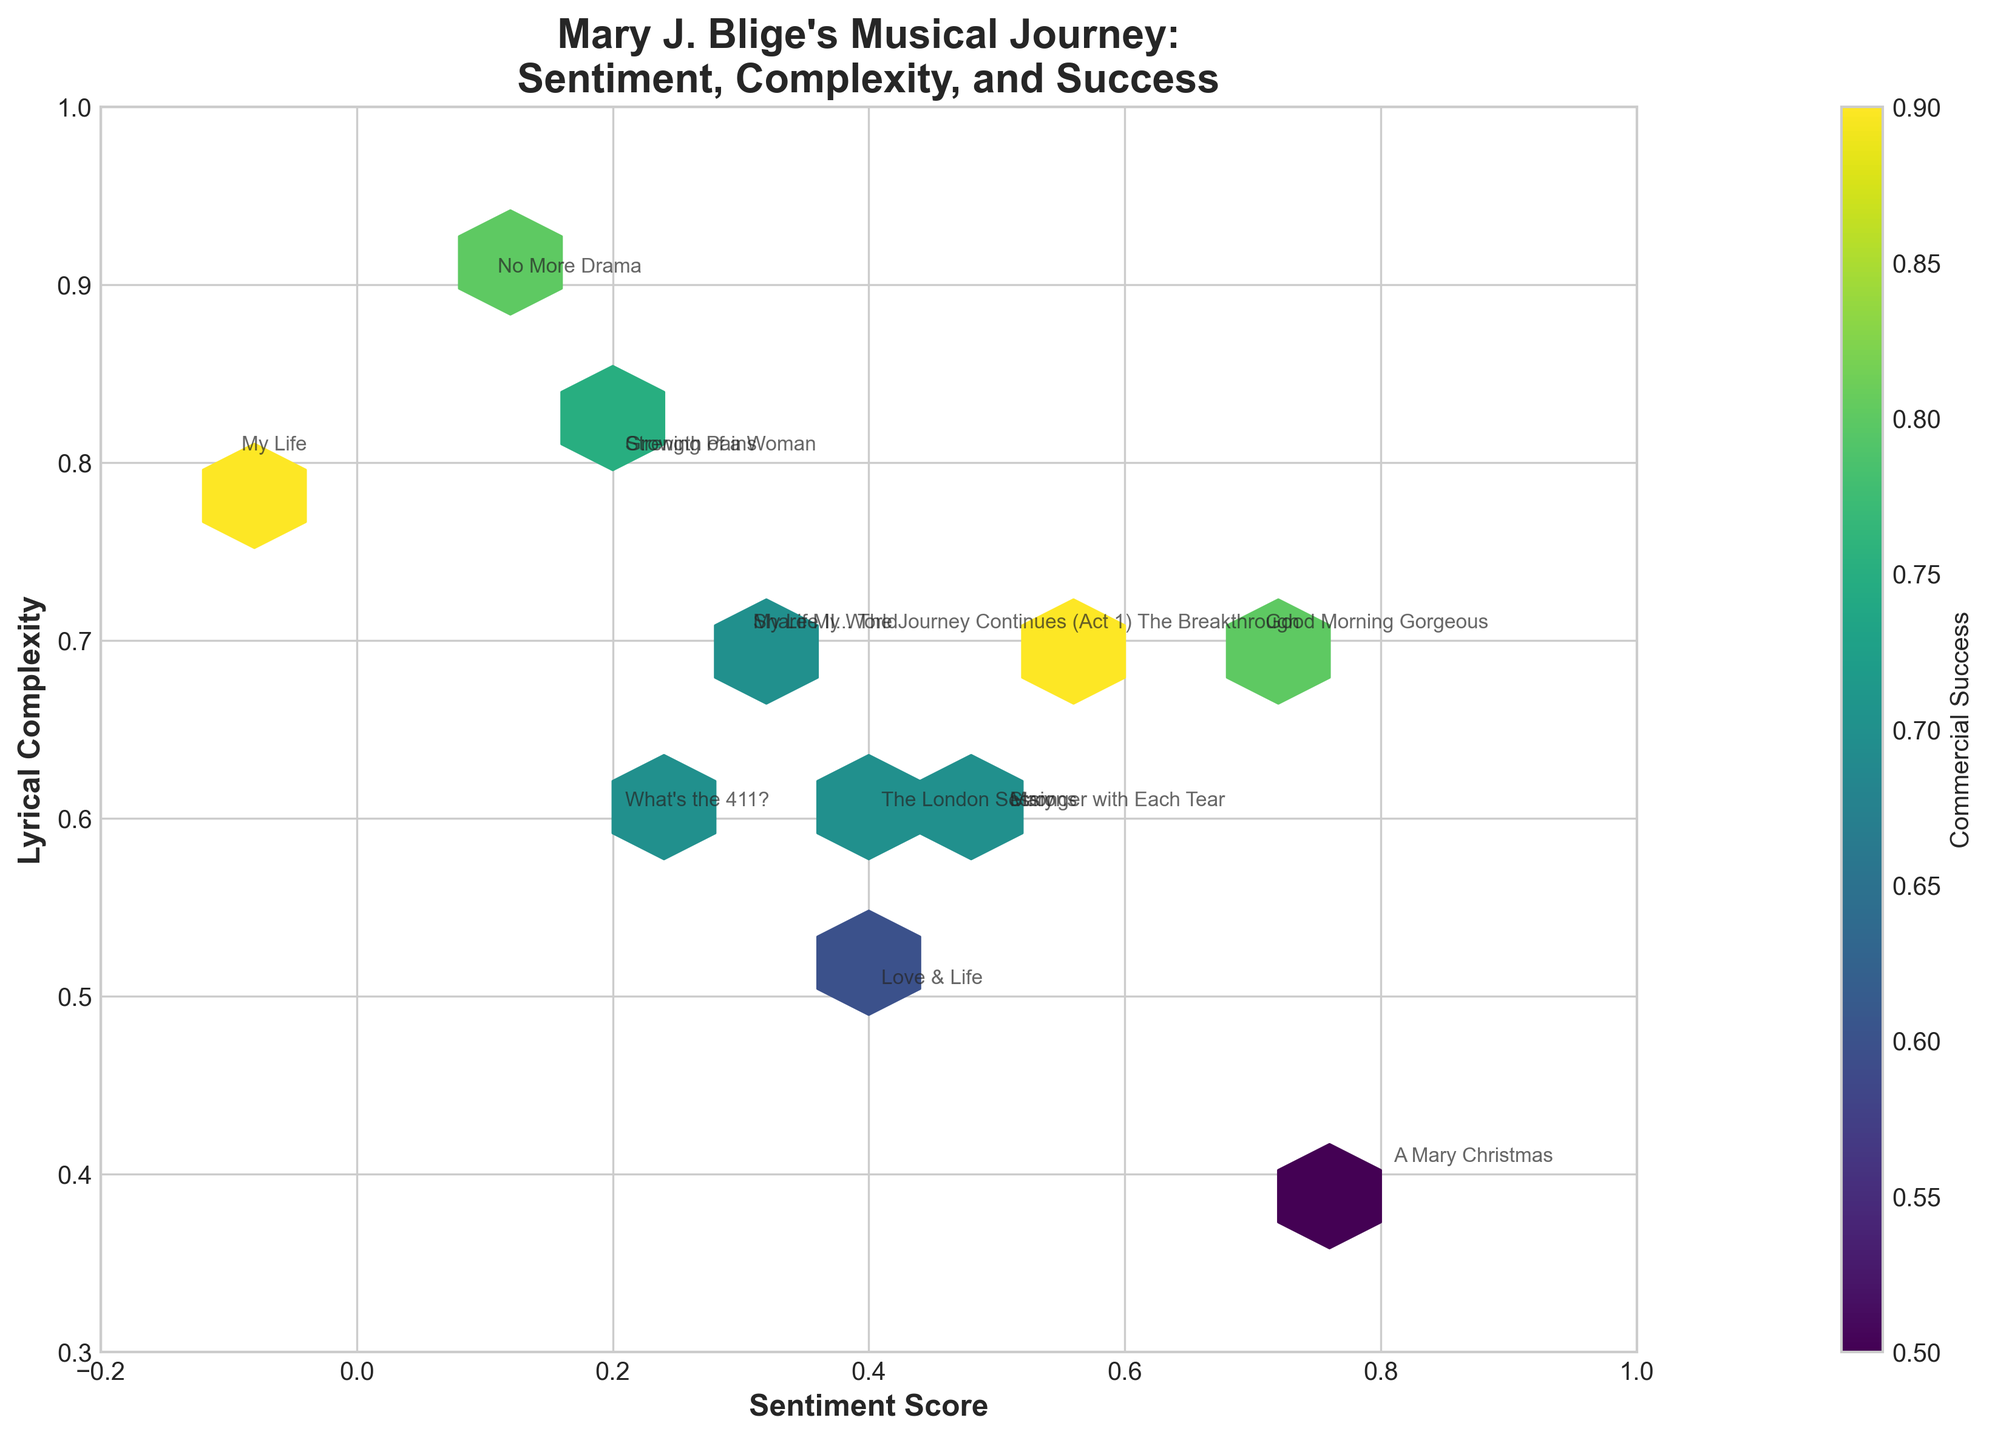what is the title of the plot? The title of the plot is typically located at the top of the figure. In this case, the title reads, "Mary J. Blige's Musical Journey: Sentiment, Complexity, and Success".
Answer: Mary J. Blige's Musical Journey: Sentiment, Complexity, and Success What are the axes labeled on the plot? The axes labels can usually be found next to the axes themselves. The x-axis is labeled as 'Sentiment Score' and the y-axis is labeled as 'Lyrical Complexity'.
Answer: Sentiment Score and Lyrical Complexity How are the colors in the hexagonal bins used in the plot? In a hexbin plot, the colors inside the hexagonal bins usually represent an additional variable. In this case, the color indicates 'Commercial Success' with values ranging and a color bar indicating the scale.
Answer: They represent 'Commercial Success' Which album has the highest sentiment score? By observing the plot, we need to look at the position on the x-axis (Sentiment Score). "A Mary Christmas" is at a sentiment score of 0.8, which appears to be the highest.
Answer: A Mary Christmas How does lyrical complexity correlate with sentiment scores in general on this plot? Examining the plot, we can see how the points are distributed. Generally, there is no strong trend; albums with various lyrical complexities also spread across different sentiment scores.
Answer: No strong correlation Which album has the highest lyrical complexity? Look at the y-axis which represents lyrical complexity. "No More Drama" has the highest position on the y-axis, indicating it has the highest lyrical complexity.
Answer: No More Drama Between "My Life" and "Love & Life", which album has a higher commercial success? To determine this, examine the color intensity of the hexagons containing these albums. "My Life" shows a higher color intensity, indicating a higher commercial success.
Answer: My Life What is the overall range of commercial success values depicted in the plot? The color bar shows the scale of the commercial success variable. Examining the color bar, the range of commercial success values is from 0.5 to 0.9.
Answer: 0.5 to 0.9 By looking at "Stronger with Each Tear" and "The London Sessions", which album has a greater lyrical complexity but similar commercial success? Compare the positions along the y-axis (lyrical complexity) and examine the color of the hexagons to ensure similar commercial success. "Stronger with Each Tear" has higher lyrical complexity with similar commercial success as "The London Sessions".
Answer: Stronger with Each Tear How many albums are plotted in the figure? Each labeled data point in the plot represents an album. By counting the labels, we find there are 14 albums plotted.
Answer: 14 